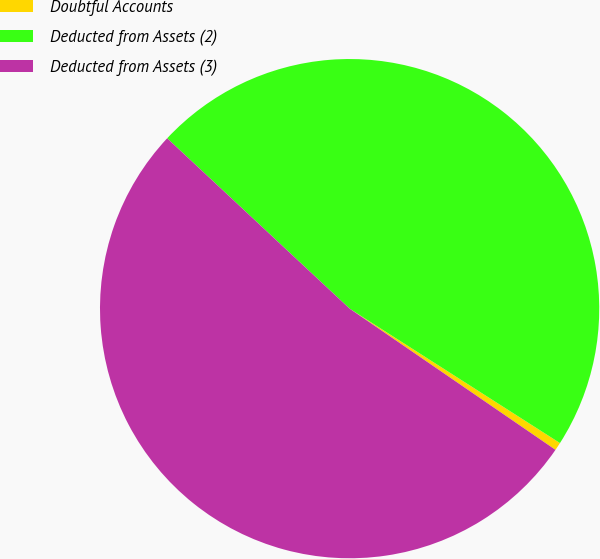<chart> <loc_0><loc_0><loc_500><loc_500><pie_chart><fcel>Doubtful Accounts<fcel>Deducted from Assets (2)<fcel>Deducted from Assets (3)<nl><fcel>0.52%<fcel>47.1%<fcel>52.39%<nl></chart> 